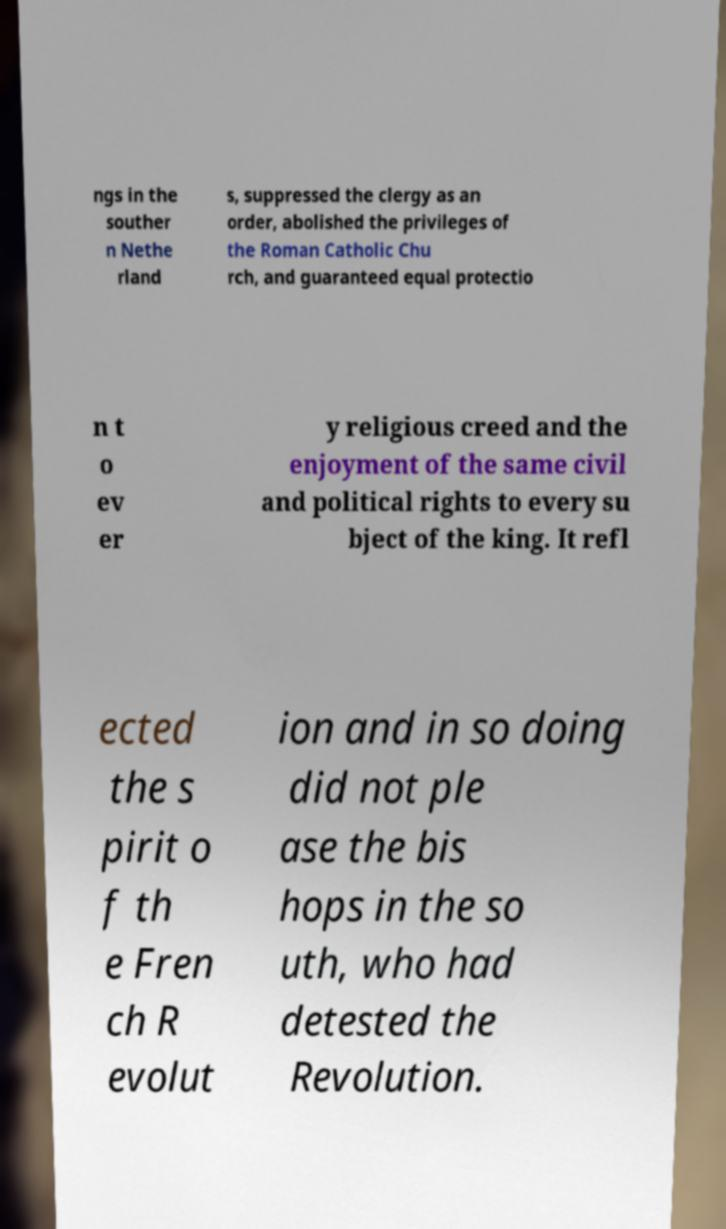What messages or text are displayed in this image? I need them in a readable, typed format. ngs in the souther n Nethe rland s, suppressed the clergy as an order, abolished the privileges of the Roman Catholic Chu rch, and guaranteed equal protectio n t o ev er y religious creed and the enjoyment of the same civil and political rights to every su bject of the king. It refl ected the s pirit o f th e Fren ch R evolut ion and in so doing did not ple ase the bis hops in the so uth, who had detested the Revolution. 